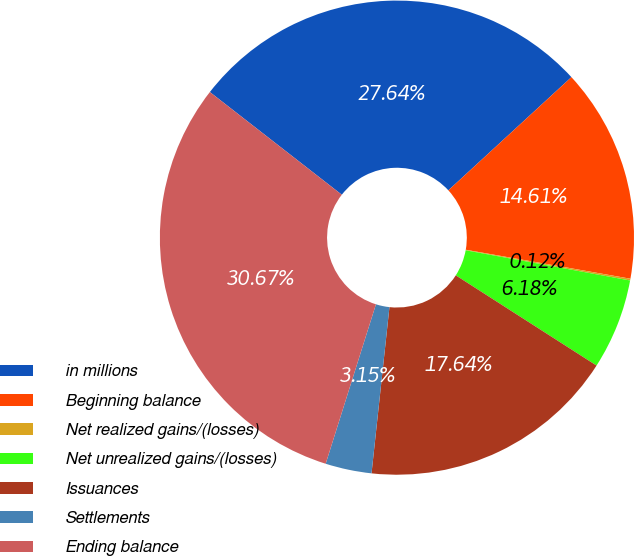<chart> <loc_0><loc_0><loc_500><loc_500><pie_chart><fcel>in millions<fcel>Beginning balance<fcel>Net realized gains/(losses)<fcel>Net unrealized gains/(losses)<fcel>Issuances<fcel>Settlements<fcel>Ending balance<nl><fcel>27.64%<fcel>14.61%<fcel>0.12%<fcel>6.18%<fcel>17.64%<fcel>3.15%<fcel>30.67%<nl></chart> 